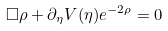Convert formula to latex. <formula><loc_0><loc_0><loc_500><loc_500>\Box \rho + \partial _ { \eta } V ( \eta ) e ^ { - 2 \rho } = 0</formula> 